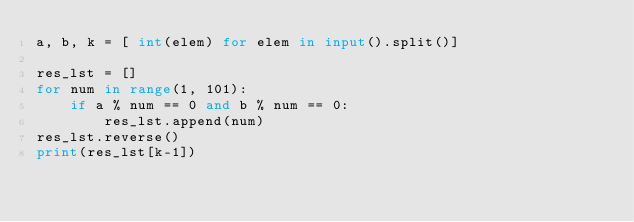Convert code to text. <code><loc_0><loc_0><loc_500><loc_500><_Python_>a, b, k = [ int(elem) for elem in input().split()]

res_lst = []
for num in range(1, 101):
    if a % num == 0 and b % num == 0:
        res_lst.append(num)
res_lst.reverse()
print(res_lst[k-1])</code> 